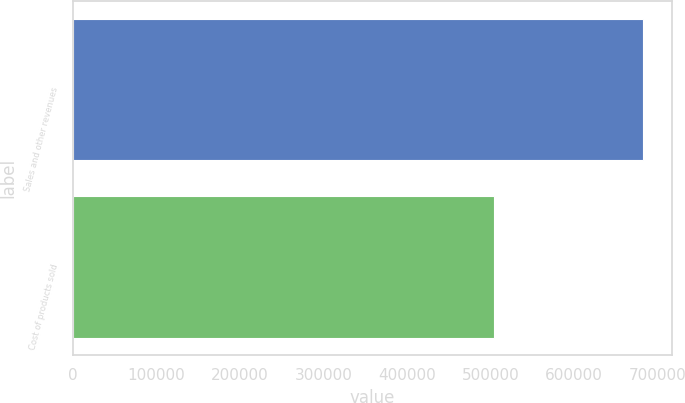Convert chart to OTSL. <chart><loc_0><loc_0><loc_500><loc_500><bar_chart><fcel>Sales and other revenues<fcel>Cost of products sold<nl><fcel>682892<fcel>504782<nl></chart> 